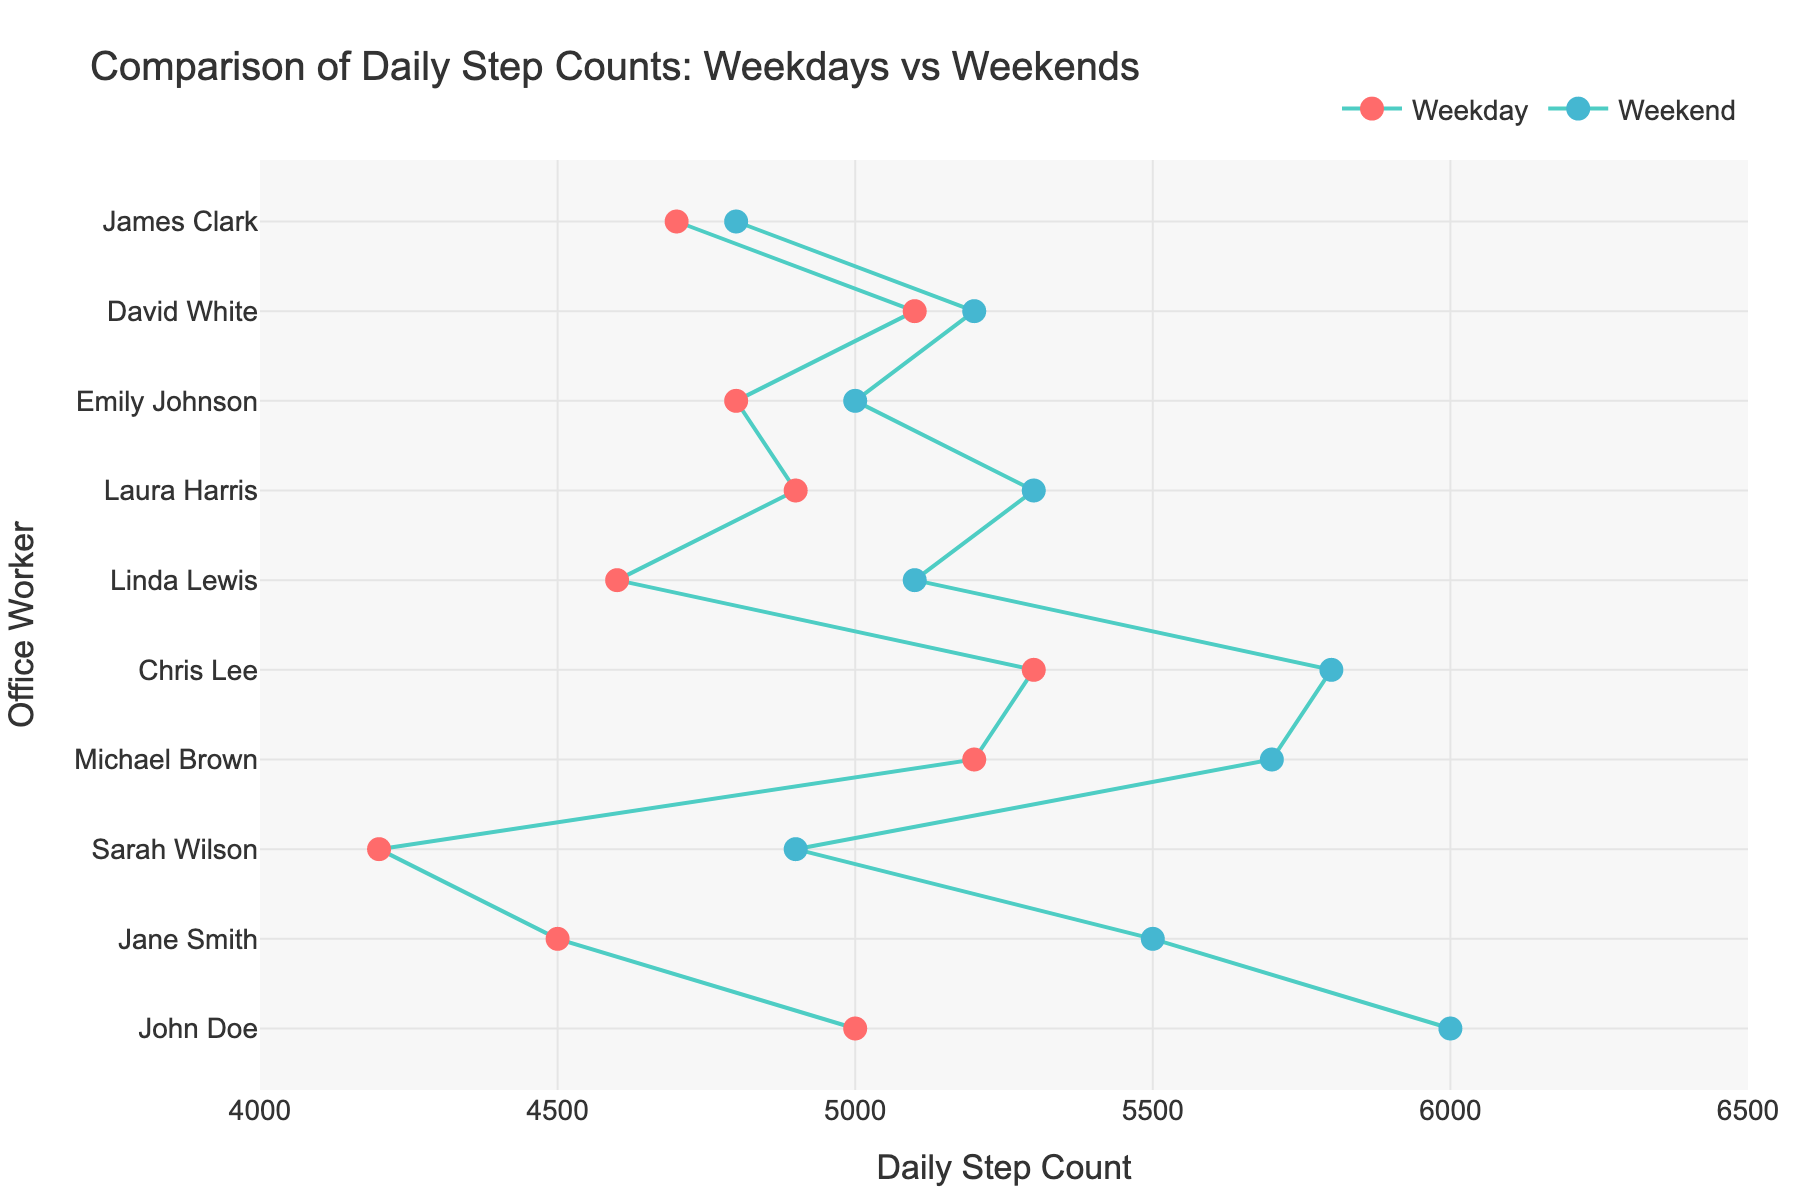What's the title of the figure? The title is written at the top of the figure and usually describes what the figure is about.
Answer: Comparison of Daily Step Counts: Weekdays vs Weekends How many office workers are included in the plot? Each office worker corresponds to one line and two markers on the plot. Count the number of unique office workers listed on the y-axis.
Answer: 10 Which office worker has the highest increase in steps from weekday to weekend? Look at the length of the lines connecting weekday and weekend markers for each office worker. The longest line shows the highest increase.
Answer: Sarah Wilson What is the weekday step count for Chris Lee? Find Chris Lee on the y-axis and refer to the corresponding weekday marker on the x-axis to identify the step count.
Answer: 5300 What's the difference in step counts between weekdays and weekends for David White? Identify the weekday and weekend steps for David White, then subtract the weekday steps from the weekend steps.
Answer: 100 Who has the least difference in steps between weekdays and weekends? Look for the shortest line connecting the two markers for each office worker. This represents the least difference.
Answer: James Clark Are there any office workers who have the same step count on weekdays and weekends? Check if any lines are horizontal, indicating no change in step counts.
Answer: No Which office worker walks more on weekdays than weekends? Observe the lines: a line sloping down to the right indicates higher weekday steps.
Answer: None What is the average weekend step count for all office workers? Sum up the weekend step counts for all office workers, then divide by the number of office workers (10).
Answer: 5420 Who has a larger increase in weekend steps: Emily Johnson or Laura Harris? Compare the increases by subtracting weekday steps from weekend steps for both Emily Johnson and Laura Harris.
Answer: Laura Harris 